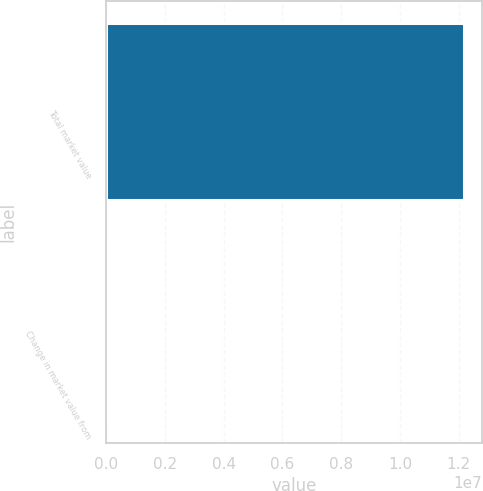<chart> <loc_0><loc_0><loc_500><loc_500><bar_chart><fcel>Total market value<fcel>Change in market value from<nl><fcel>1.21716e+07<fcel>4.41<nl></chart> 